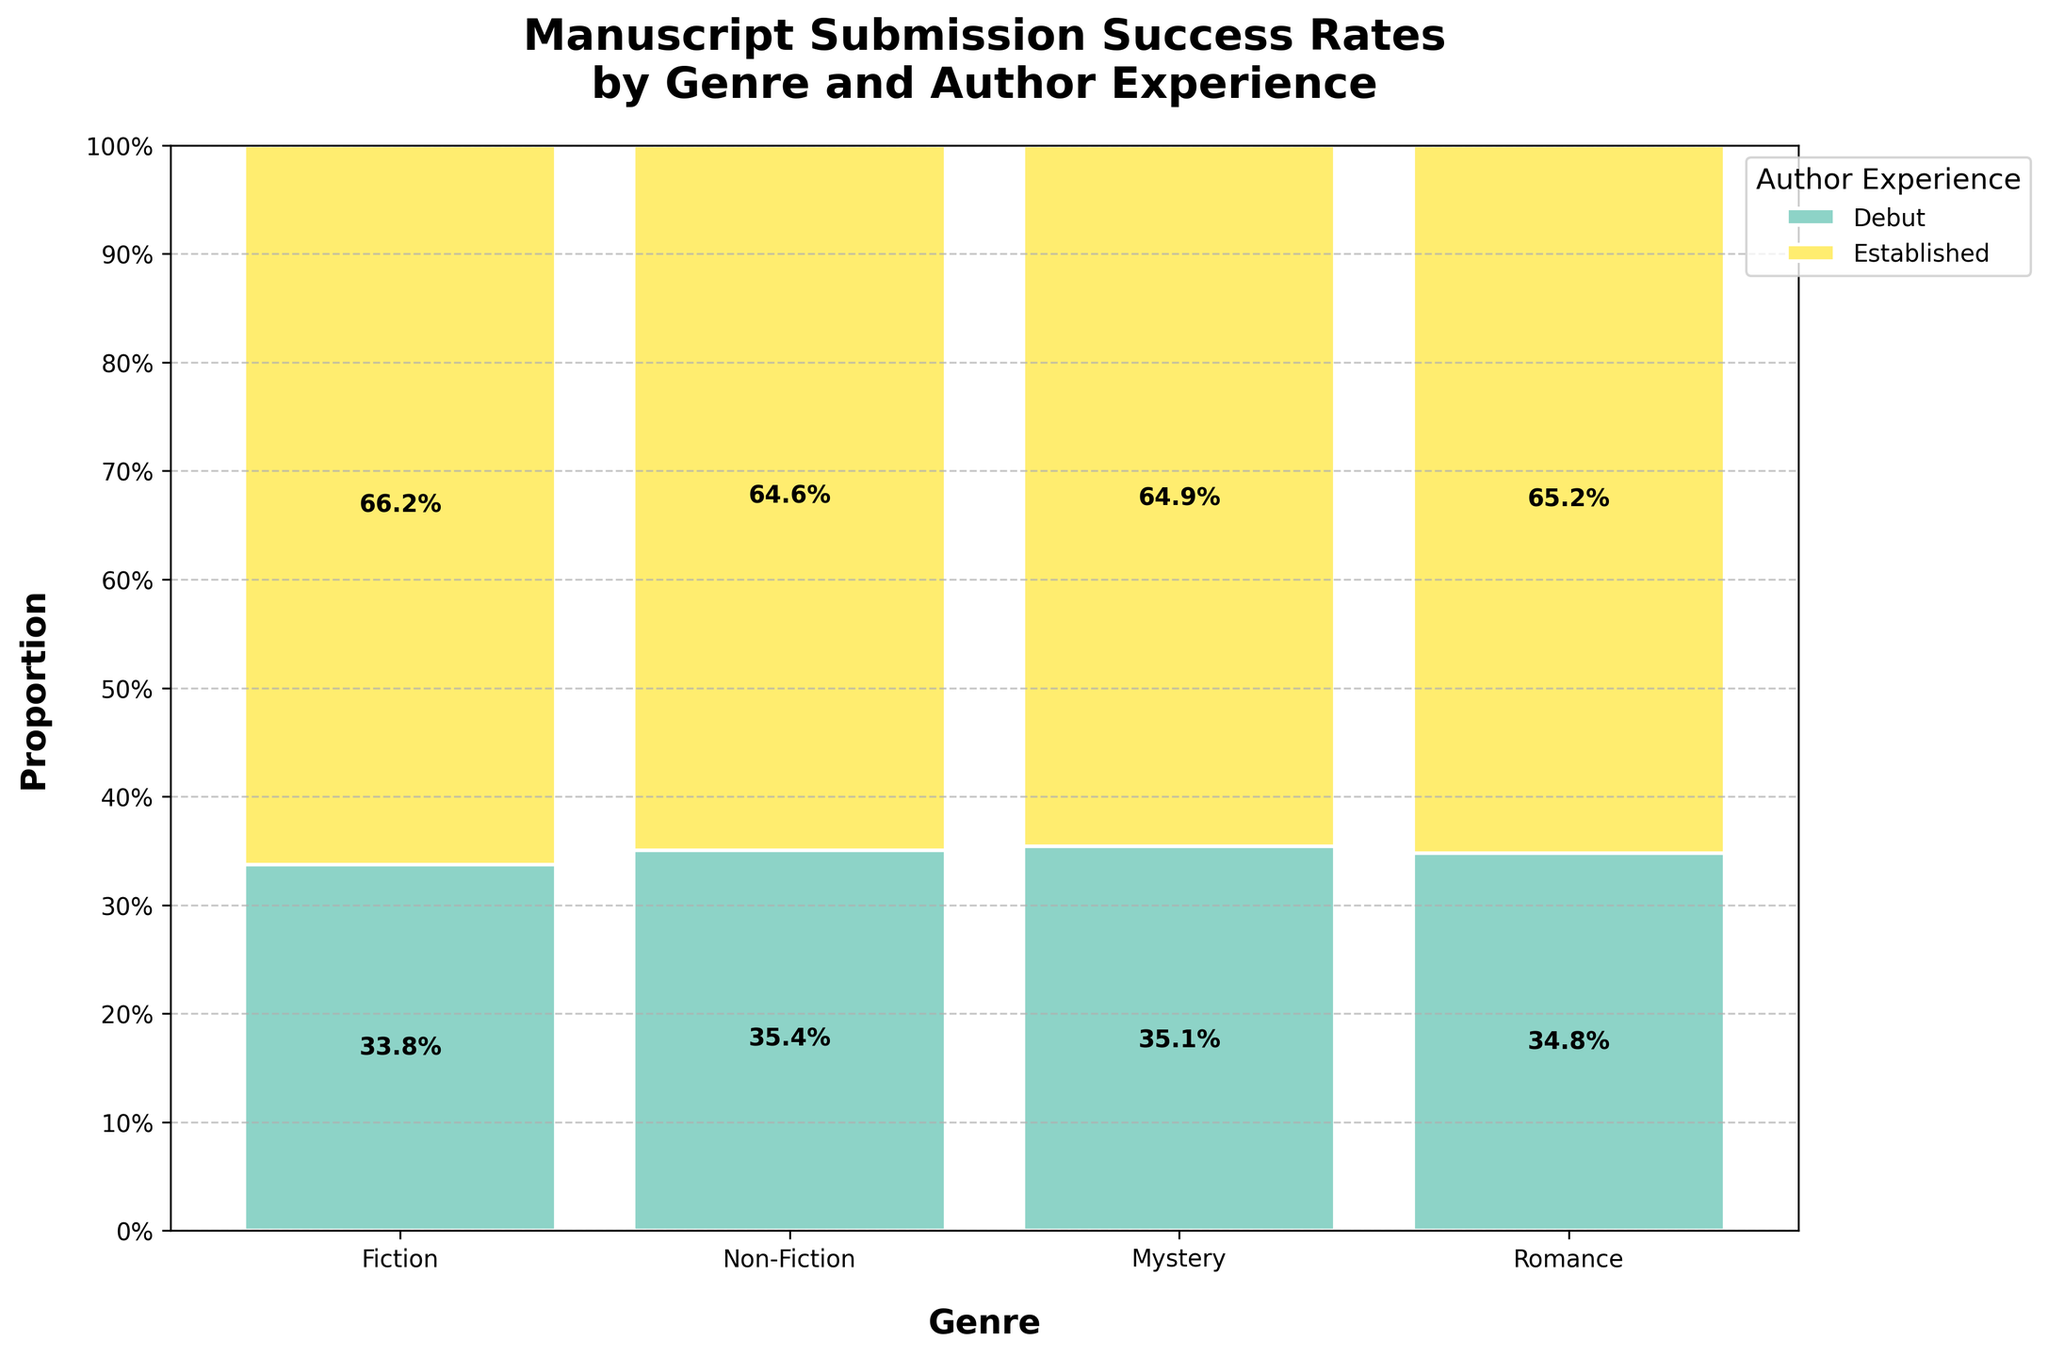What's the title of the figure? The title of the figure is displayed prominently at the top of the plot.
Answer: Manuscript Submission Success Rates by Genre and Author Experience What genre has the lowest success rate for debut authors? To determine the lowest success rate for debut authors, look at the debut author section for each genre and compare the heights of the corresponding bars. The shortest bar represents the lowest success rate.
Answer: Mystery Which genre has the highest overall success rate for established authors? Examine the proportion of established authors for each genre. The one with the tallest bar section for established authors has the highest success rate.
Answer: Romance How does the success rate for established authors in Fiction compare to their success rate in Non-Fiction? Compare the heights of the established author bar sections within the Fiction and Non-Fiction bars. Subtract the height of Non-Fiction's established author bar from Fiction's established author bar.
Answer: More successful in Fiction What's the combined success rate for debut and established authors in the Mystery genre? Sum the heights of the debut and established author bar sections within the Mystery genre to get the total. For bars in the mosaic plot, the sum equals 1 (100%).
Answer: 1 (100%) In which genre is there a greater disparity in success rates between debut and established authors? To find the greater disparity, compare the differences in height between the debut and established author sections across all genres. The genre with the largest difference has the greatest disparity.
Answer: Romance What is the approximate success rate for debut authors in the Romance genre? Identify the height of the debut author bar section within the Romance genre. This height represents the success rate.
Answer: 0.17 (17%) Which genre has more balanced success rates between debut and established authors? Look for the genre where the difference in bar heights between debut and established authors is smallest, indicating balanced success rates.
Answer: Non-Fiction How does the success rate of debut authors in Fiction compare to debut authors in Mystery? Compare the heights of the debut author bar sections within Fiction and Mystery. The taller bar indicates a higher success rate.
Answer: Higher in Fiction 